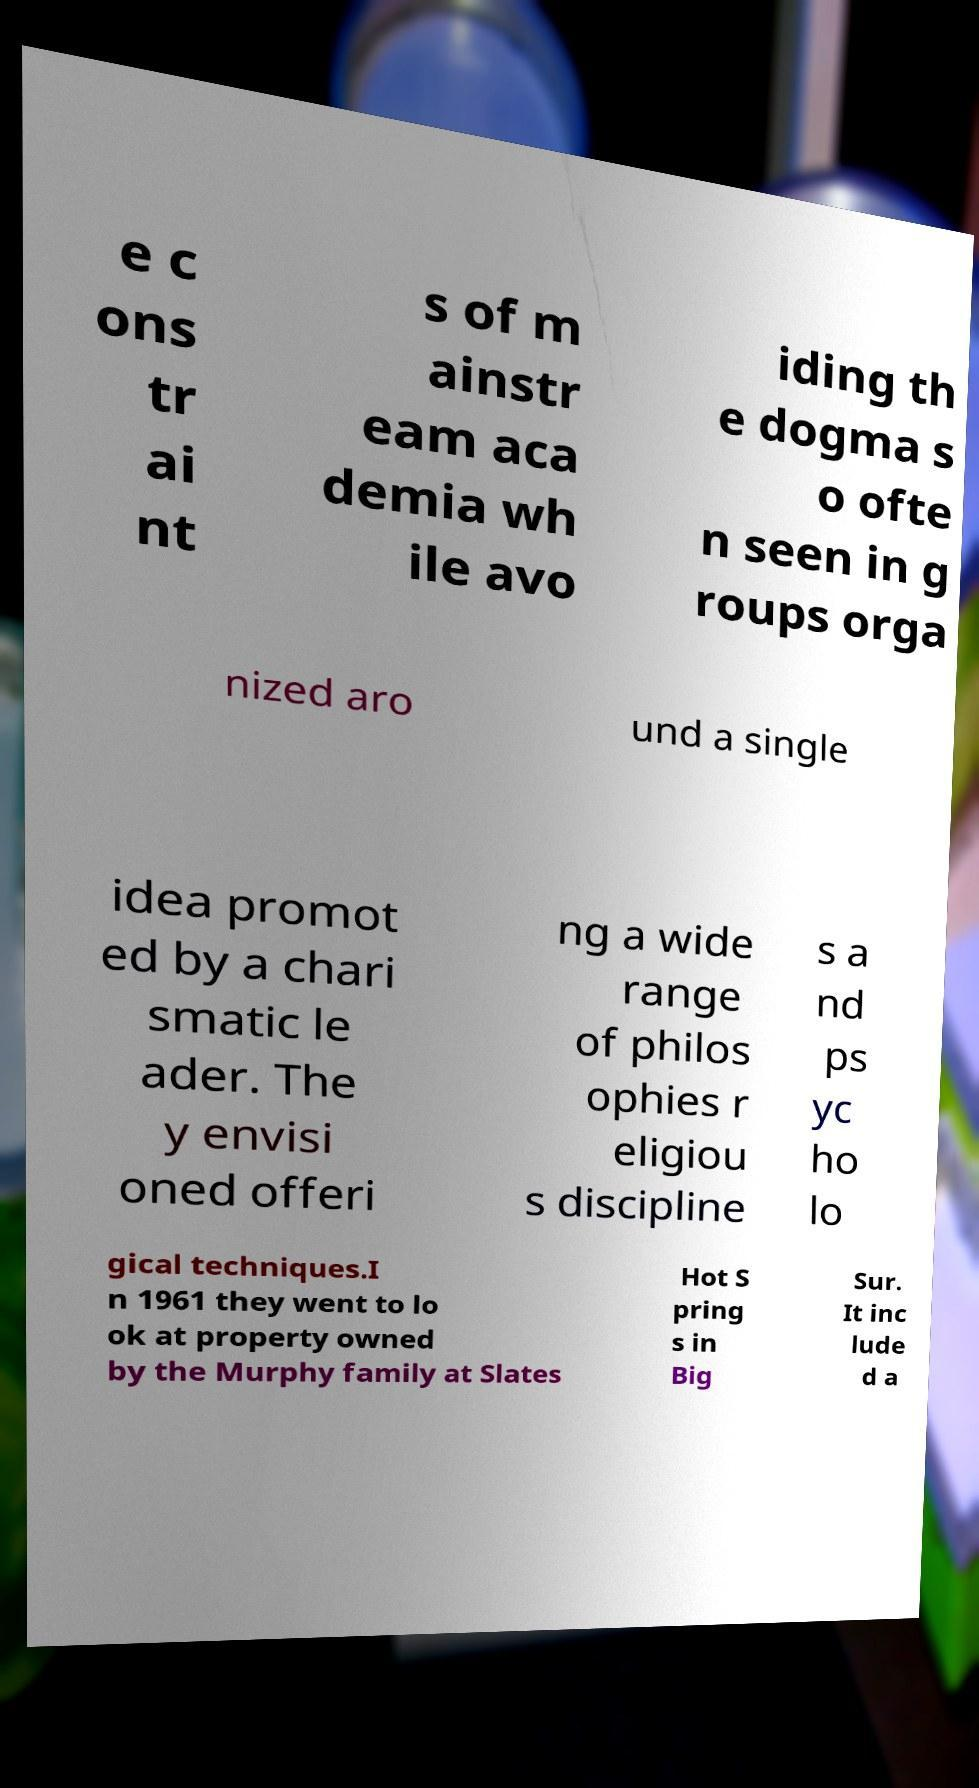Could you extract and type out the text from this image? e c ons tr ai nt s of m ainstr eam aca demia wh ile avo iding th e dogma s o ofte n seen in g roups orga nized aro und a single idea promot ed by a chari smatic le ader. The y envisi oned offeri ng a wide range of philos ophies r eligiou s discipline s a nd ps yc ho lo gical techniques.I n 1961 they went to lo ok at property owned by the Murphy family at Slates Hot S pring s in Big Sur. It inc lude d a 